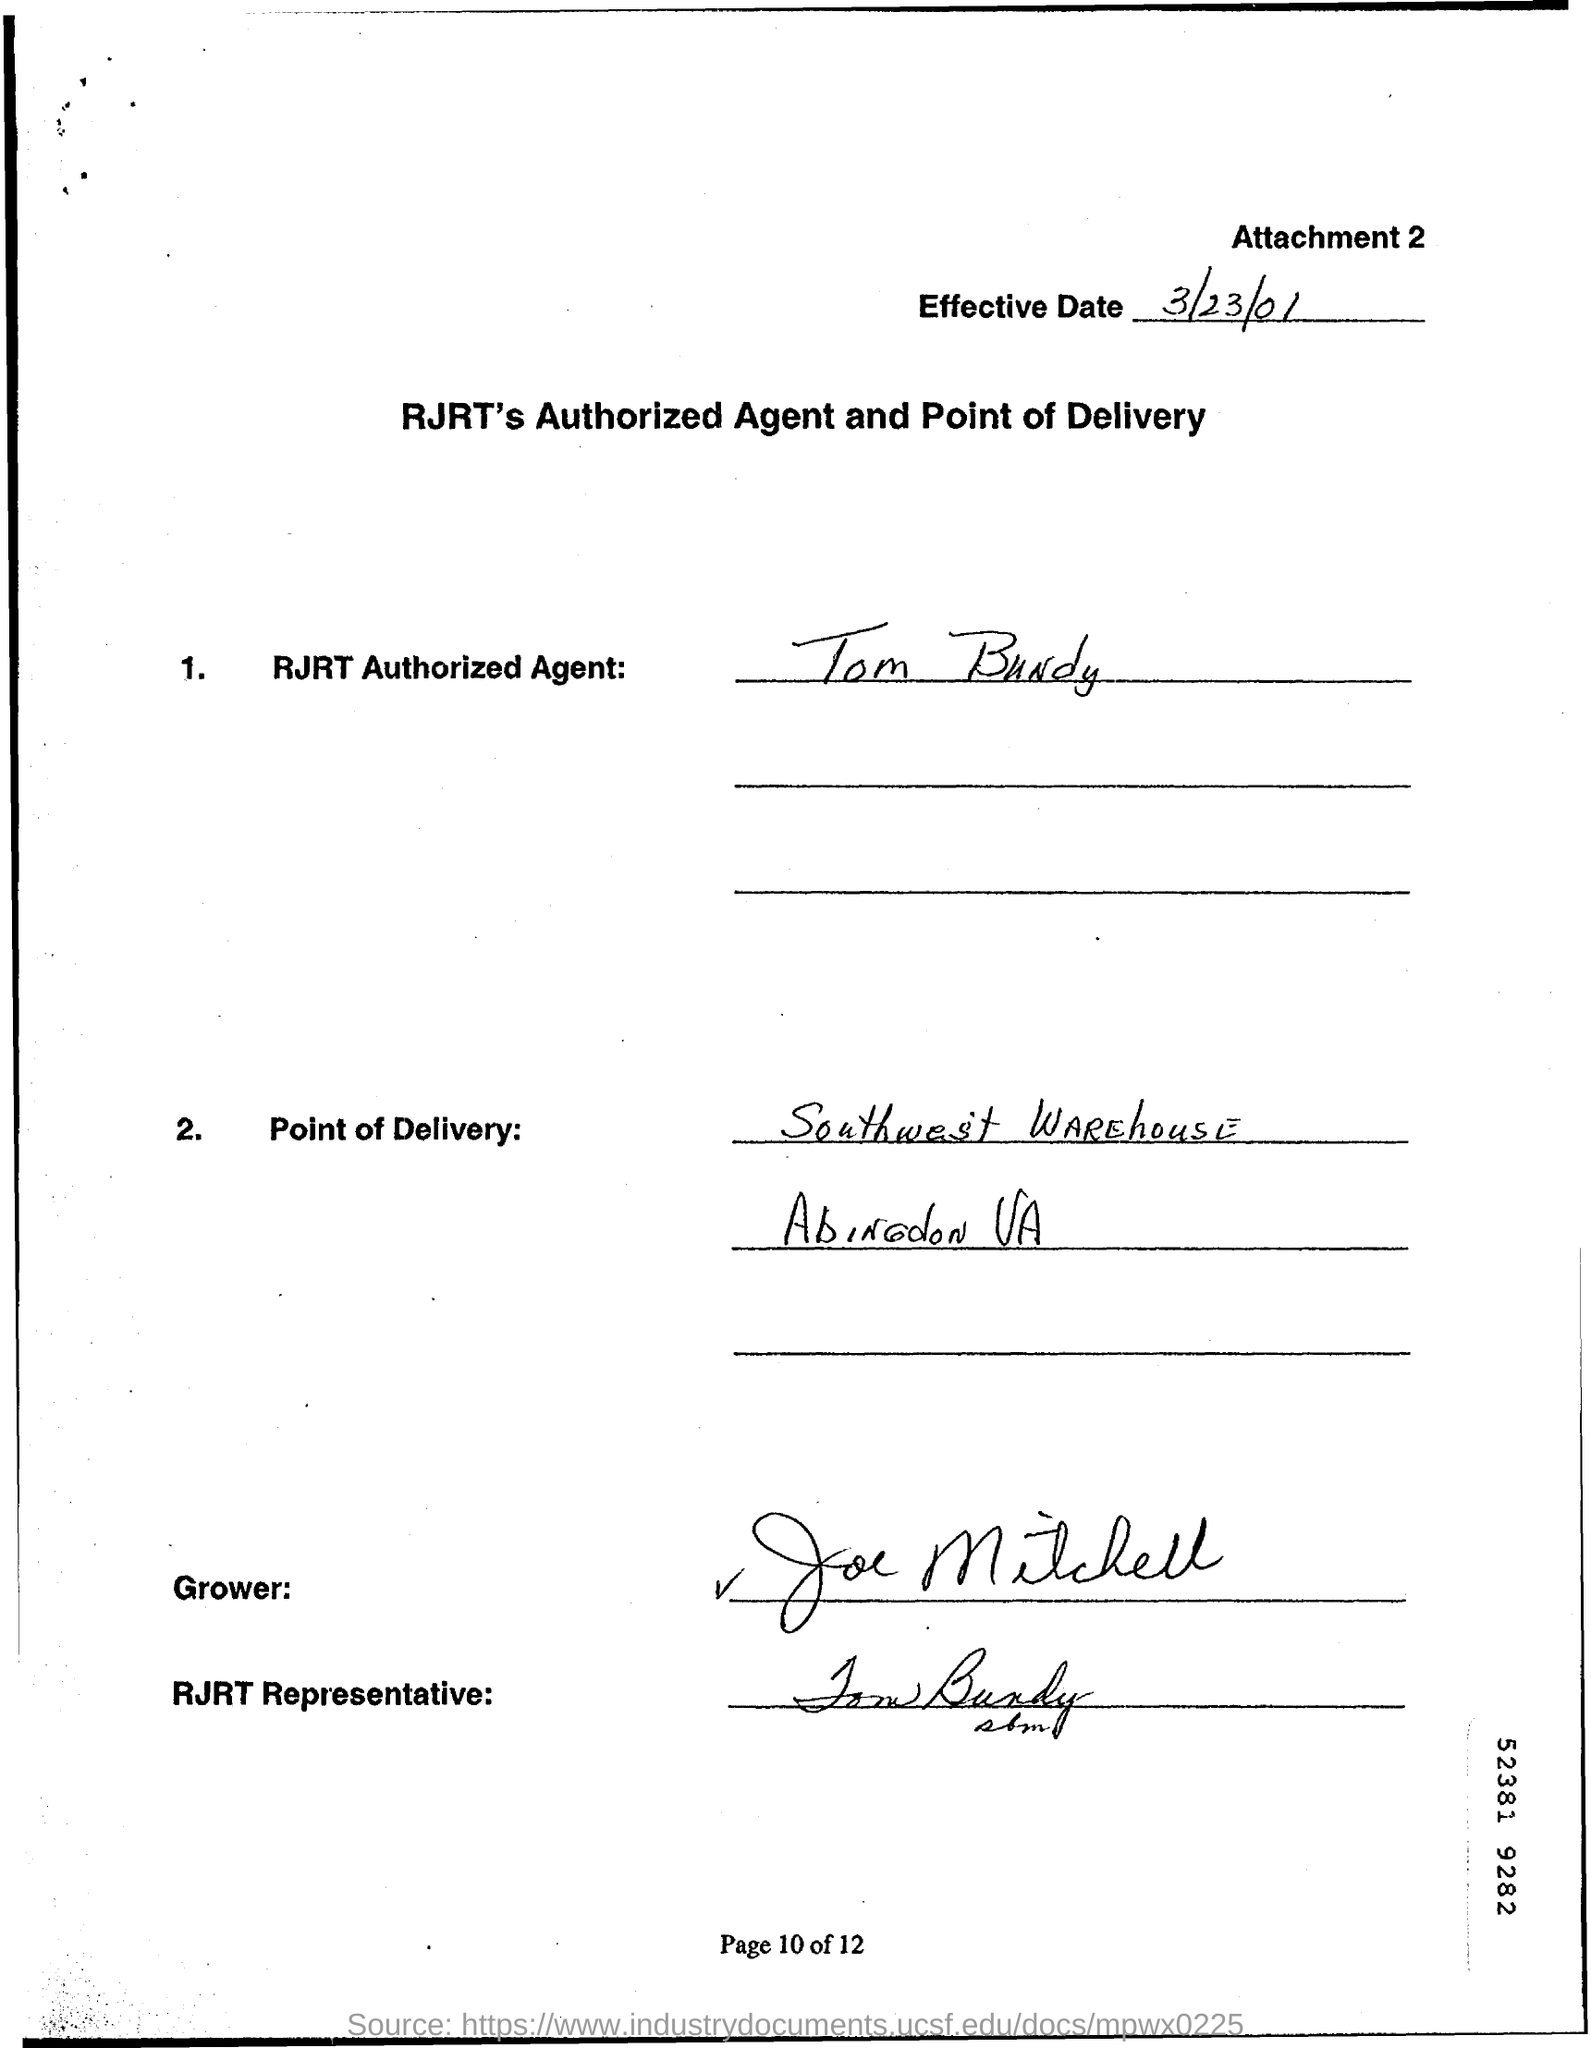What is the Effective Date?
Your answer should be compact. 3/23/01. Who is the RJRT Authorized Agent?
Give a very brief answer. Tom Bundy. What is the Point of Delivery?
Provide a succinct answer. Southwest Warehouse, Abingdon, VA. 